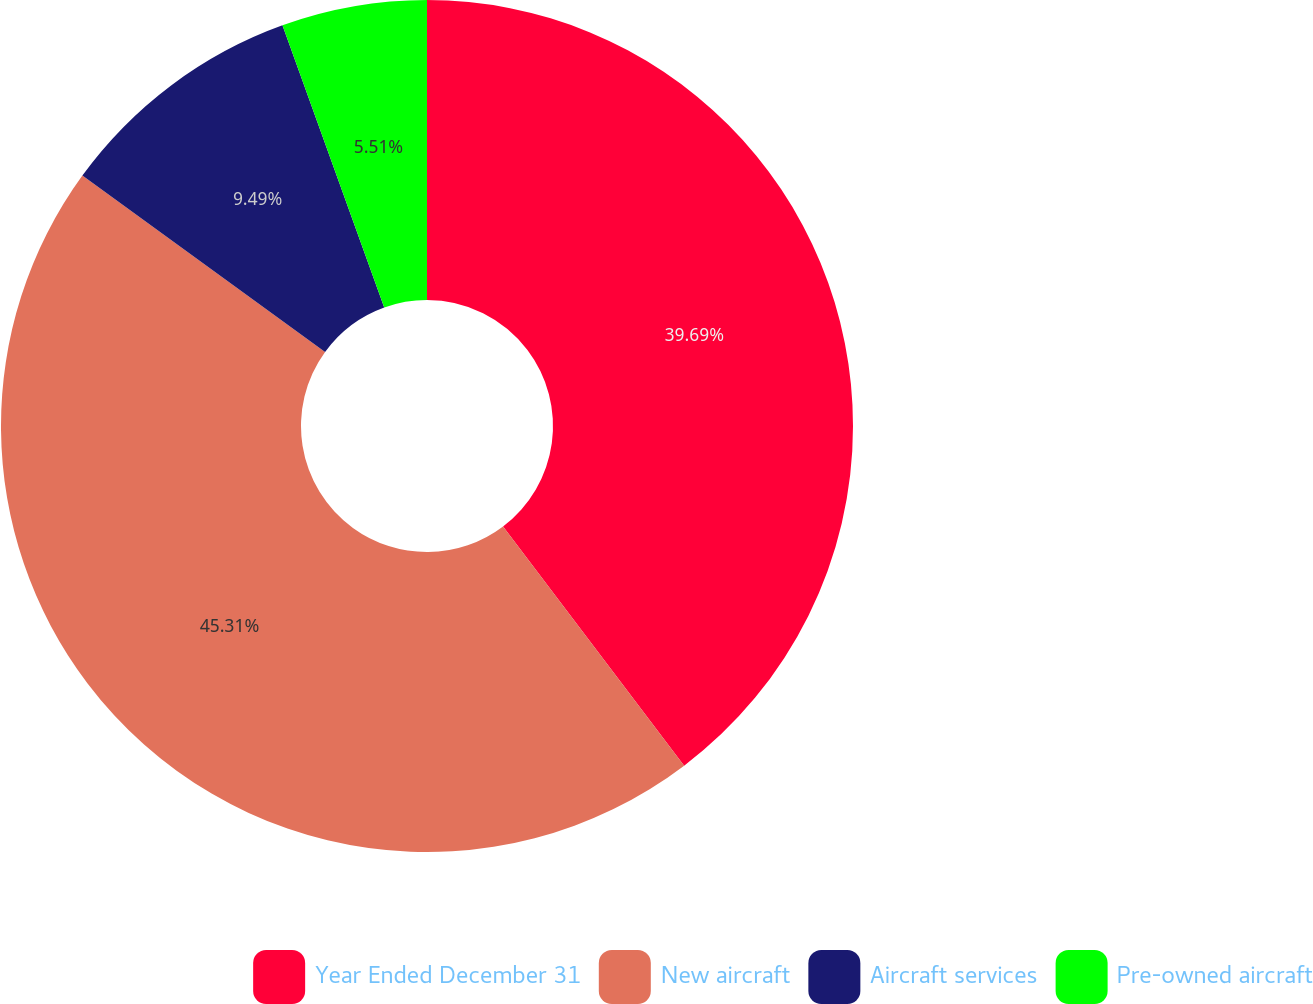<chart> <loc_0><loc_0><loc_500><loc_500><pie_chart><fcel>Year Ended December 31<fcel>New aircraft<fcel>Aircraft services<fcel>Pre-owned aircraft<nl><fcel>39.69%<fcel>45.32%<fcel>9.49%<fcel>5.51%<nl></chart> 